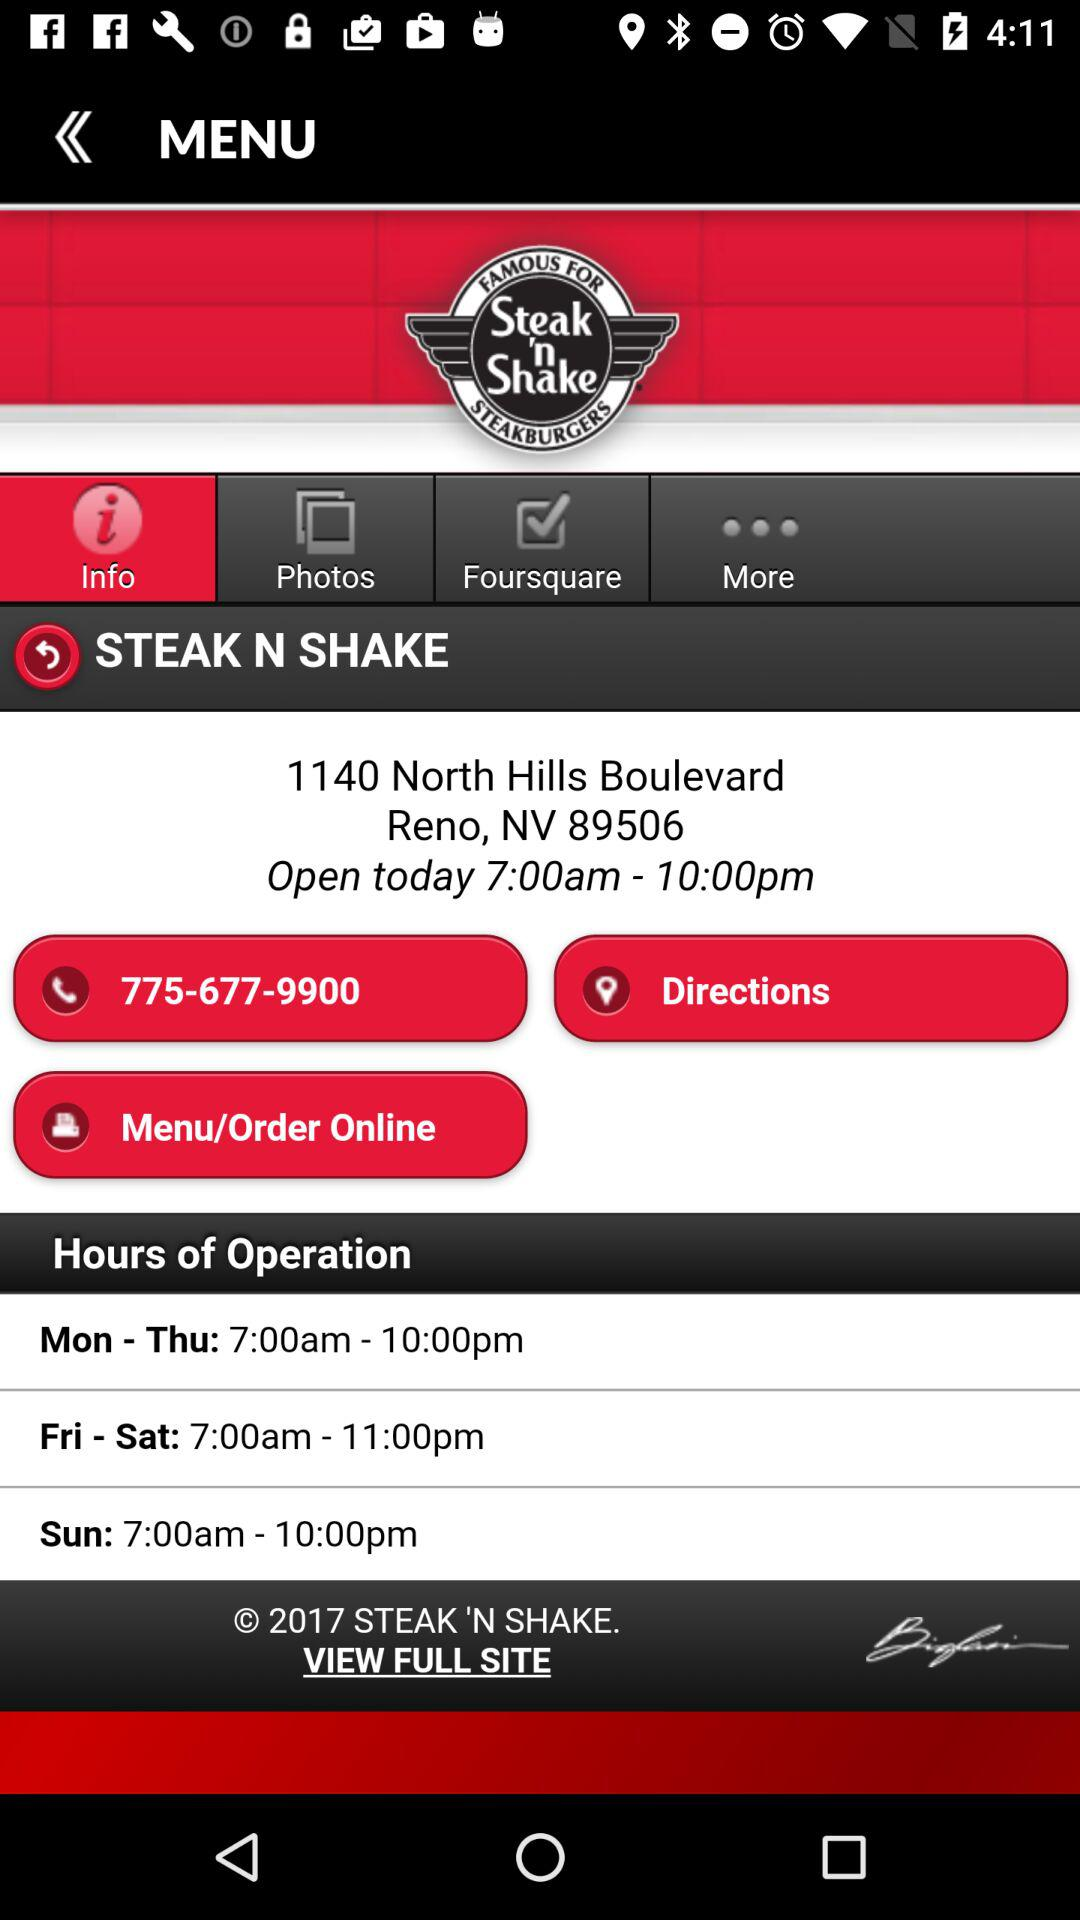What is the phone number? The phone number is 775-677-9900. 